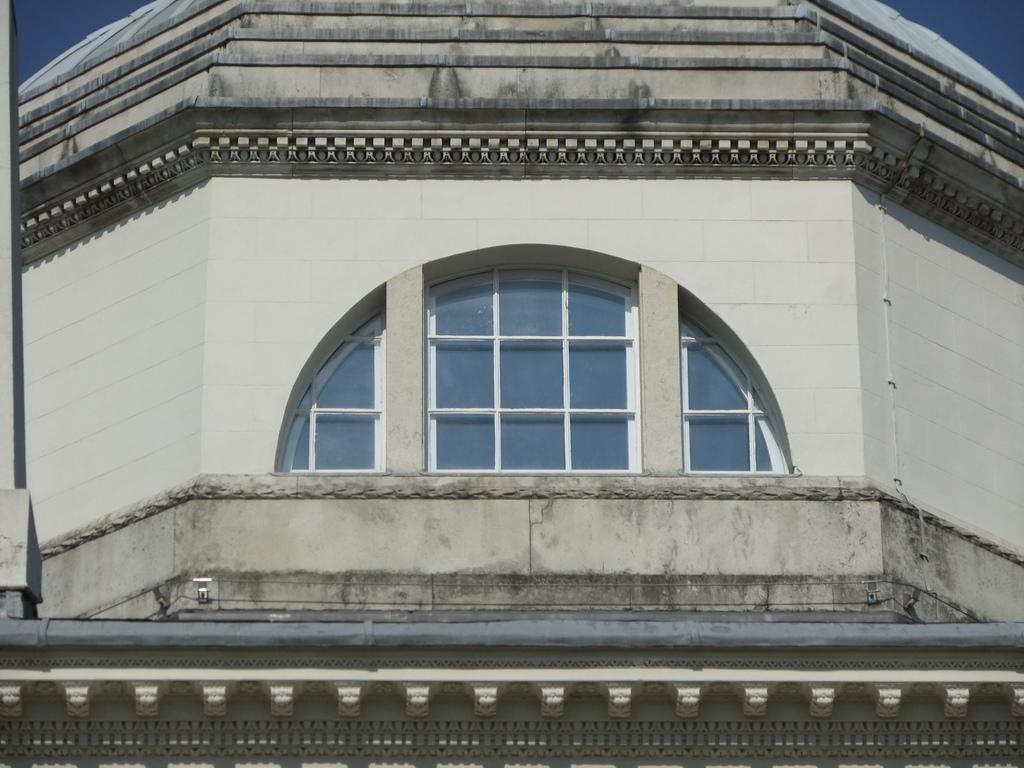Please provide a concise description of this image. In this image I can see the building which is cream and black in color and I can see its windows which are white and blue in color. In the background I can see the sky which is blue in color. 